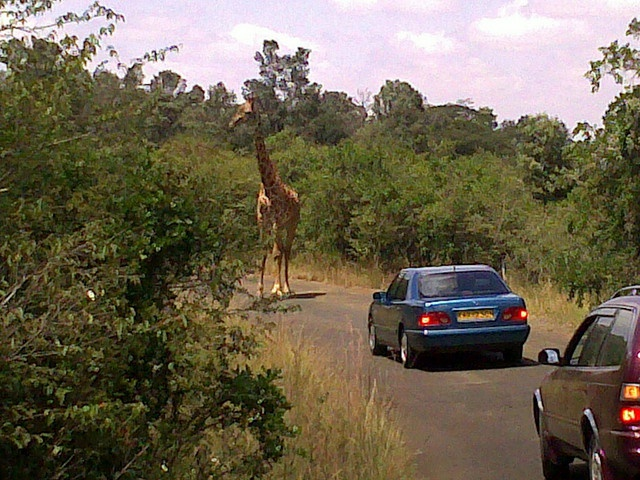Describe the objects in this image and their specific colors. I can see car in gray, black, and maroon tones, car in gray, black, and navy tones, and giraffe in gray, maroon, olive, and black tones in this image. 